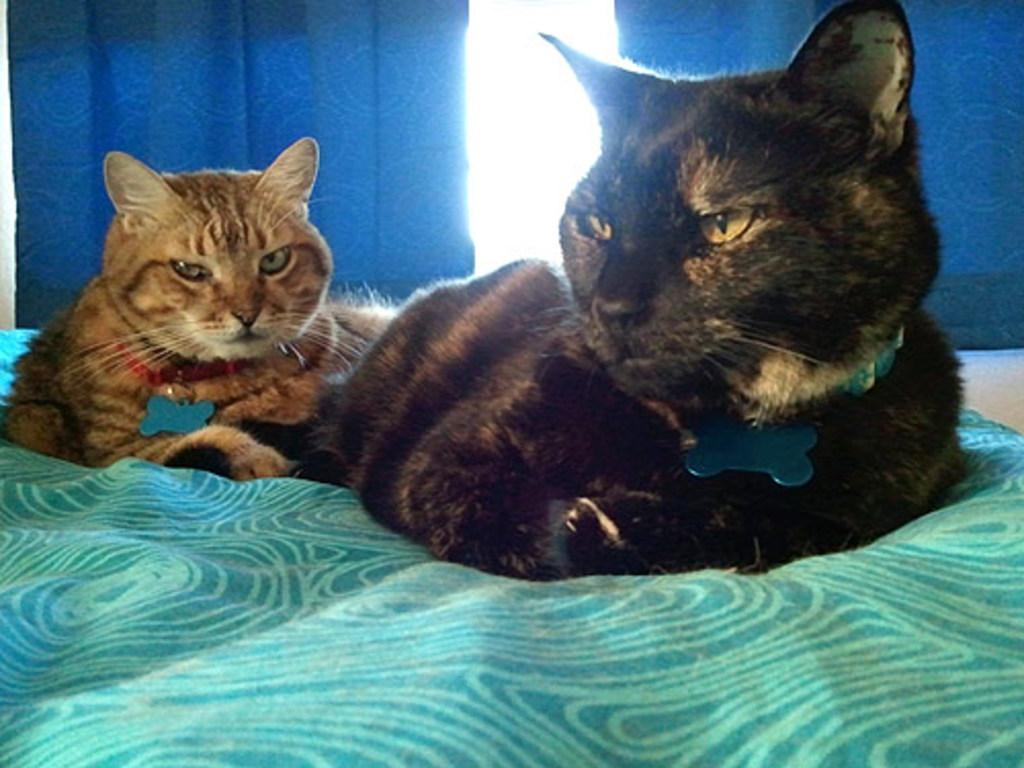What animals can be seen on the bed in the foreground? There are two cats on the bed in the foreground. What color are the curtains visible in the background? There are two blue curtains in the background. What object is located in the middle of the image? There appears to be a glass in the middle of the image. What type of advertisement can be seen on the base of the glass in the image? There is no advertisement present on the base of the glass in the image. How many attempts did the cats make to climb the curtains in the image? The image does not show the cats attempting to climb the curtains, so it cannot be determined how many attempts they made. 